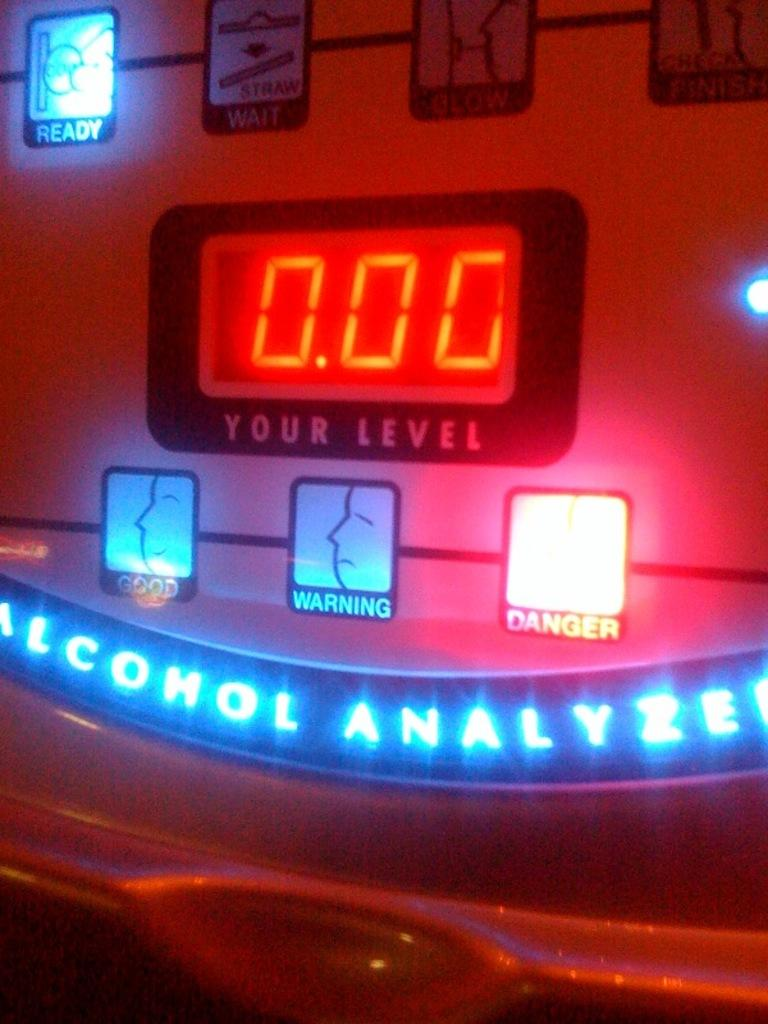<image>
Offer a succinct explanation of the picture presented. An alcohol analyzer is showing that the alcohol level tested was 0.00. 